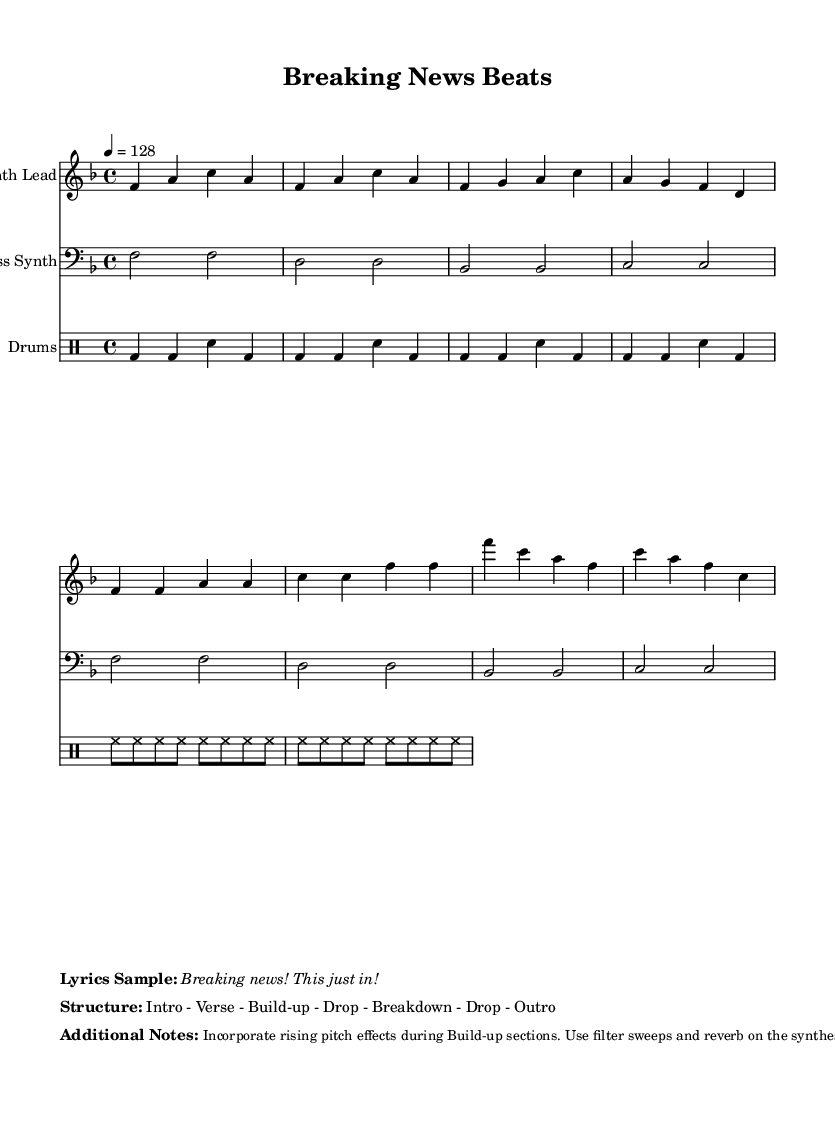What is the key signature of this music? The key signature is F major, which has one flat (B flat).
Answer: F major What is the time signature of this music? The time signature is 4/4, indicating four beats per measure.
Answer: 4/4 What is the tempo marking of the piece? The tempo marking is quarter note equals 128 BPM, indicating a lively pace.
Answer: 128 How many repetitions does the bass line have? The bass line is repeated twice, as indicated in the notation.
Answer: 2 What is the structure of the composition? The structure consists of Intro, Verse, Build-up, Drop, Breakdown, Drop, and Outro sections.
Answer: Intro - Verse - Build-up - Drop - Breakdown - Drop - Outro During which section does the synthesizer lead have rising pitch effects? Rising pitch effects are incorporated during the Build-up section to enhance tension.
Answer: Build-up What is the main theme of the lyrics? The main theme of the lyrics emphasizes "Breaking news" to indicate the urgency of the information.
Answer: Breaking news! 